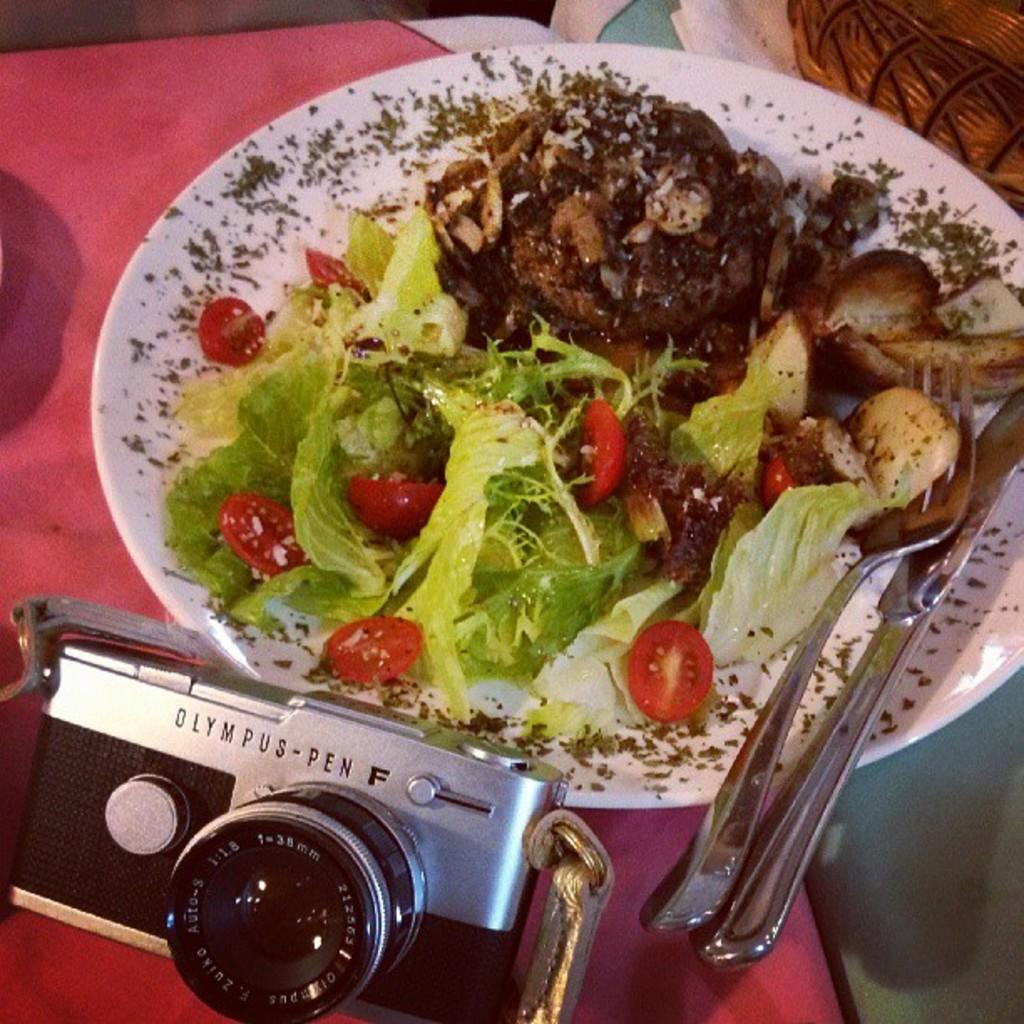What type of container is visible in the image? There is a wooden basket in the image. What is placed on the plate in the image? There is a food item on the plate in the image. What utensils are present in the image? There is a knife and a fork in the image. What device is used to capture images in the image? There is a camera in the image. What color is the copper smoke emanating from the food item in the image? There is no copper or smoke present in the image; it features a wooden basket, plate, food item, knife, fork, and camera. 